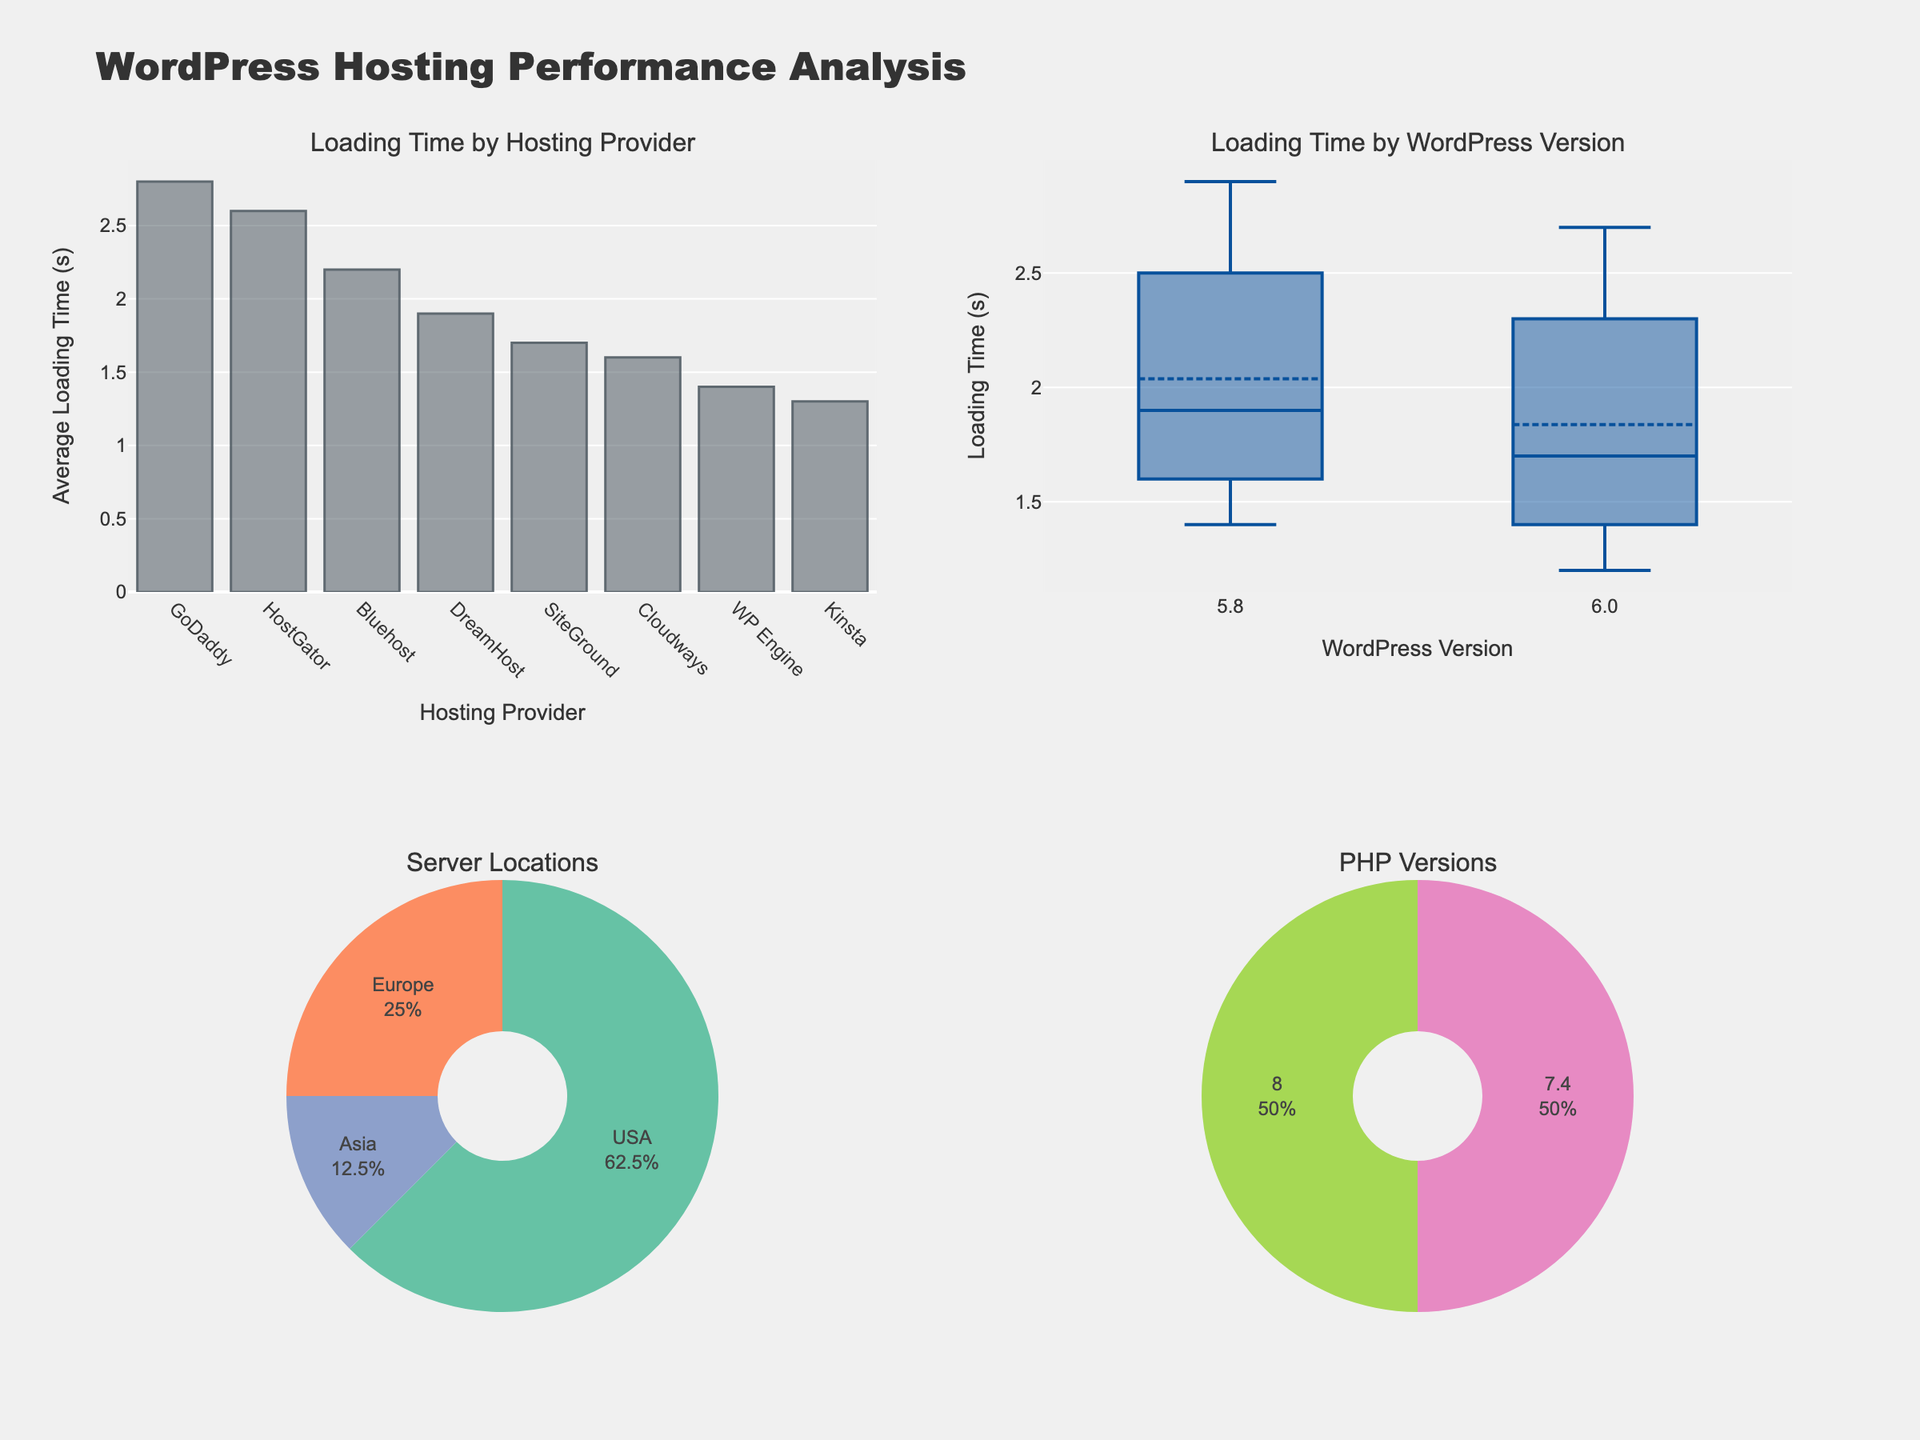Which hosting provider has the highest average loading time? The bar chart titled "Loading Time by Hosting Provider" shows the average loading time for each provider on the x-axis. The highest bar corresponds to GoDaddy, indicating the highest average loading time.
Answer: GoDaddy What is the average loading time for SiteGround? The bar chart shows average loading times for each hosting provider. By locating SiteGround's bar and noting its height on the y-axis, the average loading time for SiteGround is 1.7 seconds.
Answer: 1.7 seconds Which WordPress version has a lower median loading time based on the box plot? The box plot titled "Loading Time by WordPress Version" displays loading times for versions 5.8 and 6.0. The median is marked by the central line in the boxes. The box for version 6.0 has a lower central line than version 5.8, indicating a lower median loading time.
Answer: Version 6.0 How many server locations are represented in the data? The pie chart titled "Server Locations" displays the different server locations. Observing the number of distinct segments, there are three server locations represented: USA, Europe, and Asia.
Answer: 3 What percentage of the websites are hosted in Europe? The pie chart for "Server Locations" shows a segment labeled with the percentage. The segment corresponding to Europe has a label that indicates its percentage of the total, 25%.
Answer: 25% Which hosting provider has the lowest average loading time, and what is that time? In the bar chart, the shortest bar denotes the lowest average loading time. Observing the chart, WP Engine has the shortest bar, indicating the lowest average loading time of 1.4 seconds.
Answer: WP Engine, 1.4 seconds Is there a greater variation in loading times for WordPress version 5.8 or 6.0? The box plot for "Loading Time by WordPress Version" illustrates the spread of data points through the length of the whiskers and the interquartile range. Version 5.8 shows longer whiskers and a wider box, indicating greater variation compared to version 6.0.
Answer: Version 5.8 What is the percentage of websites using PHP version 8.0? The pie chart titled "PHP Versions" presents the share of websites using different PHP versions. The segment for PHP 8.0 has a percentage label that indicates 50%.
Answer: 50% Between Bluehost and DreamHost, which hosting provider has a faster average loading time? Comparing the bars corresponding to Bluehost and DreamHost in the bar chart, DreamHost has a shorter bar, representing a faster average loading time of 1.9 seconds compared to Bluehost's 2.2 seconds.
Answer: DreamHost Which server location hosts the most websites? The pie chart for "Server Locations" displays the share of websites for each location. The largest segment corresponds to the USA, indicating it hosts the most websites.
Answer: USA 